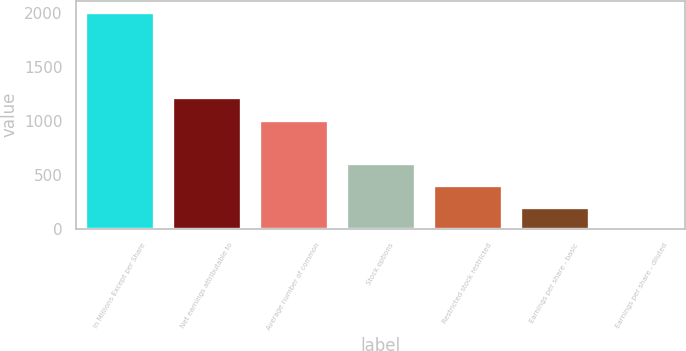<chart> <loc_0><loc_0><loc_500><loc_500><bar_chart><fcel>In Millions Except per Share<fcel>Net earnings attributable to<fcel>Average number of common<fcel>Stock options<fcel>Restricted stock restricted<fcel>Earnings per share - basic<fcel>Earnings per share - diluted<nl><fcel>2015<fcel>1221.3<fcel>1008.47<fcel>605.87<fcel>404.57<fcel>203.27<fcel>1.97<nl></chart> 